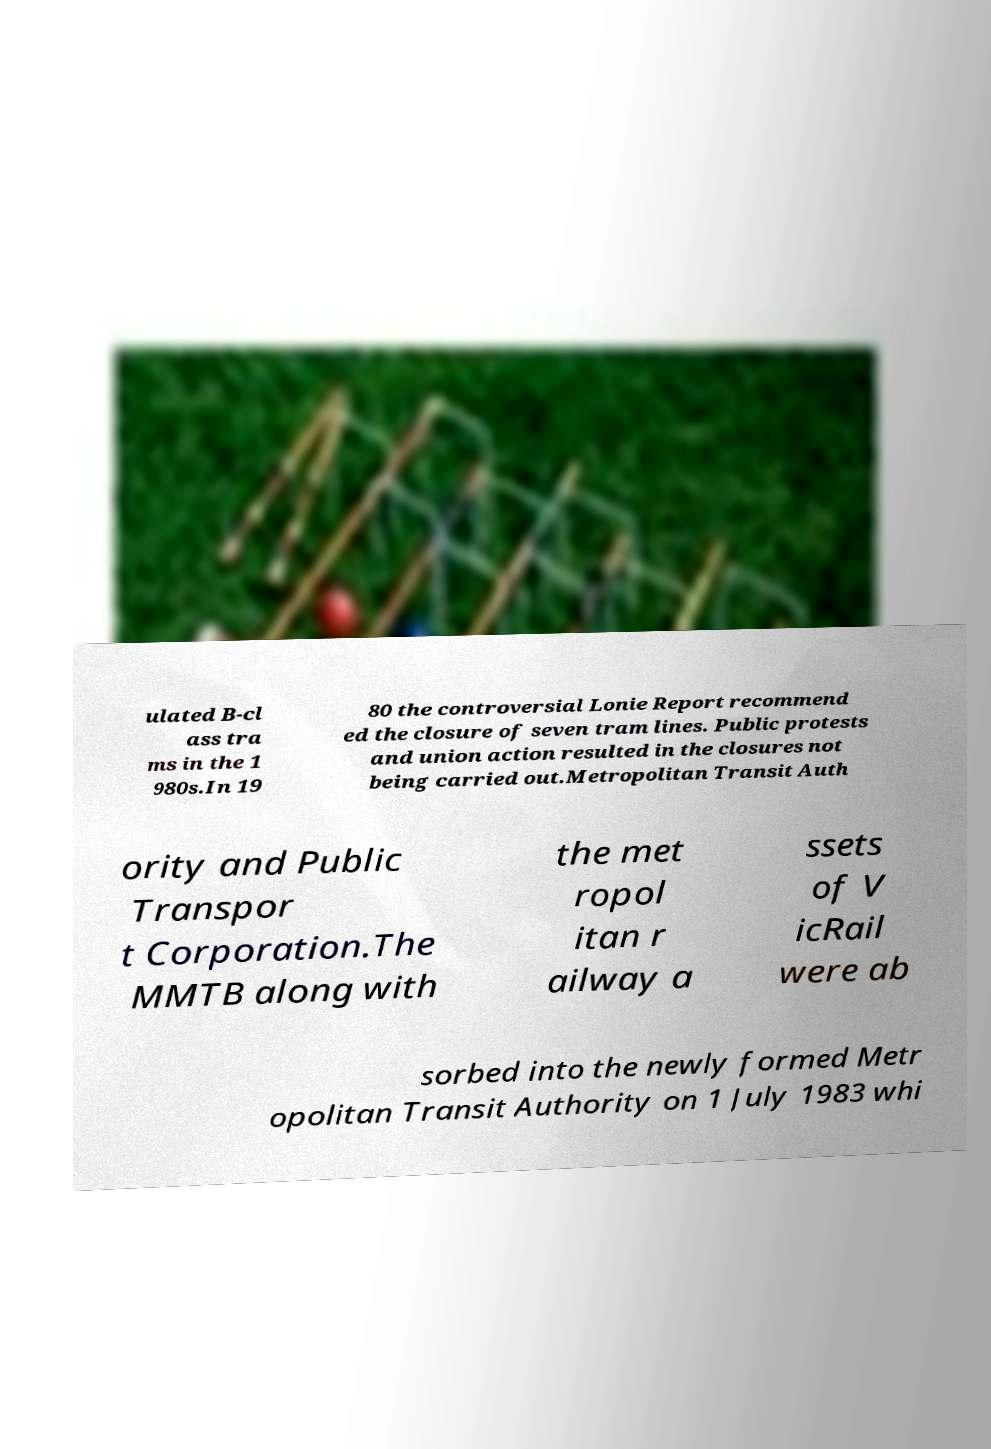Please read and relay the text visible in this image. What does it say? ulated B-cl ass tra ms in the 1 980s.In 19 80 the controversial Lonie Report recommend ed the closure of seven tram lines. Public protests and union action resulted in the closures not being carried out.Metropolitan Transit Auth ority and Public Transpor t Corporation.The MMTB along with the met ropol itan r ailway a ssets of V icRail were ab sorbed into the newly formed Metr opolitan Transit Authority on 1 July 1983 whi 